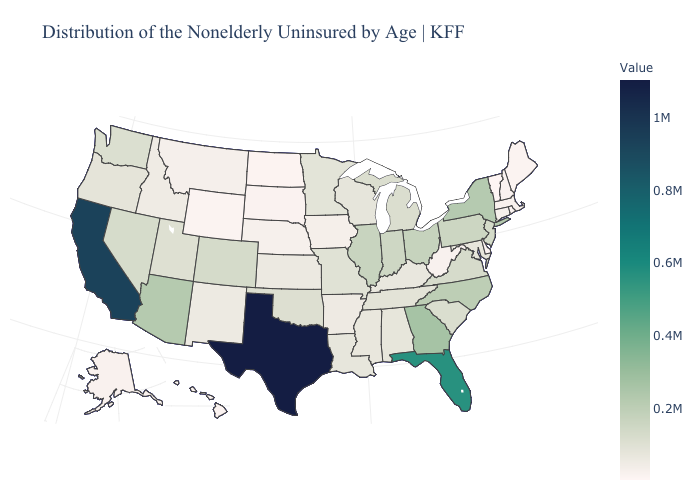Does Connecticut have the lowest value in the Northeast?
Quick response, please. No. Does California have the highest value in the West?
Quick response, please. Yes. Does Alaska have the lowest value in the West?
Give a very brief answer. No. 